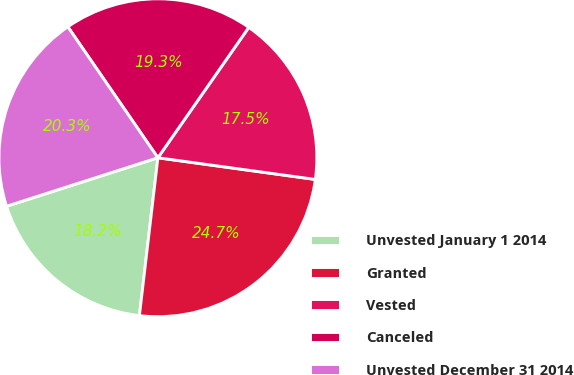<chart> <loc_0><loc_0><loc_500><loc_500><pie_chart><fcel>Unvested January 1 2014<fcel>Granted<fcel>Vested<fcel>Canceled<fcel>Unvested December 31 2014<nl><fcel>18.21%<fcel>24.68%<fcel>17.49%<fcel>19.28%<fcel>20.35%<nl></chart> 